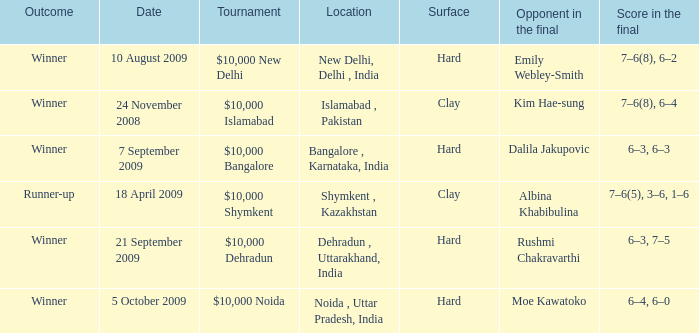What is the material of the surface in the dehradun , uttarakhand, india location Hard. 